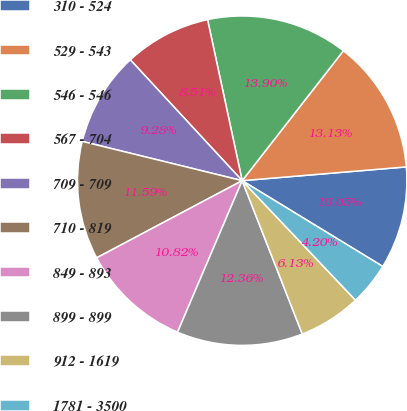Convert chart to OTSL. <chart><loc_0><loc_0><loc_500><loc_500><pie_chart><fcel>310 - 524<fcel>529 - 543<fcel>546 - 546<fcel>567 - 704<fcel>709 - 709<fcel>710 - 819<fcel>849 - 893<fcel>899 - 899<fcel>912 - 1619<fcel>1781 - 3500<nl><fcel>10.05%<fcel>13.13%<fcel>13.9%<fcel>8.51%<fcel>9.28%<fcel>11.59%<fcel>10.82%<fcel>12.36%<fcel>6.13%<fcel>4.2%<nl></chart> 